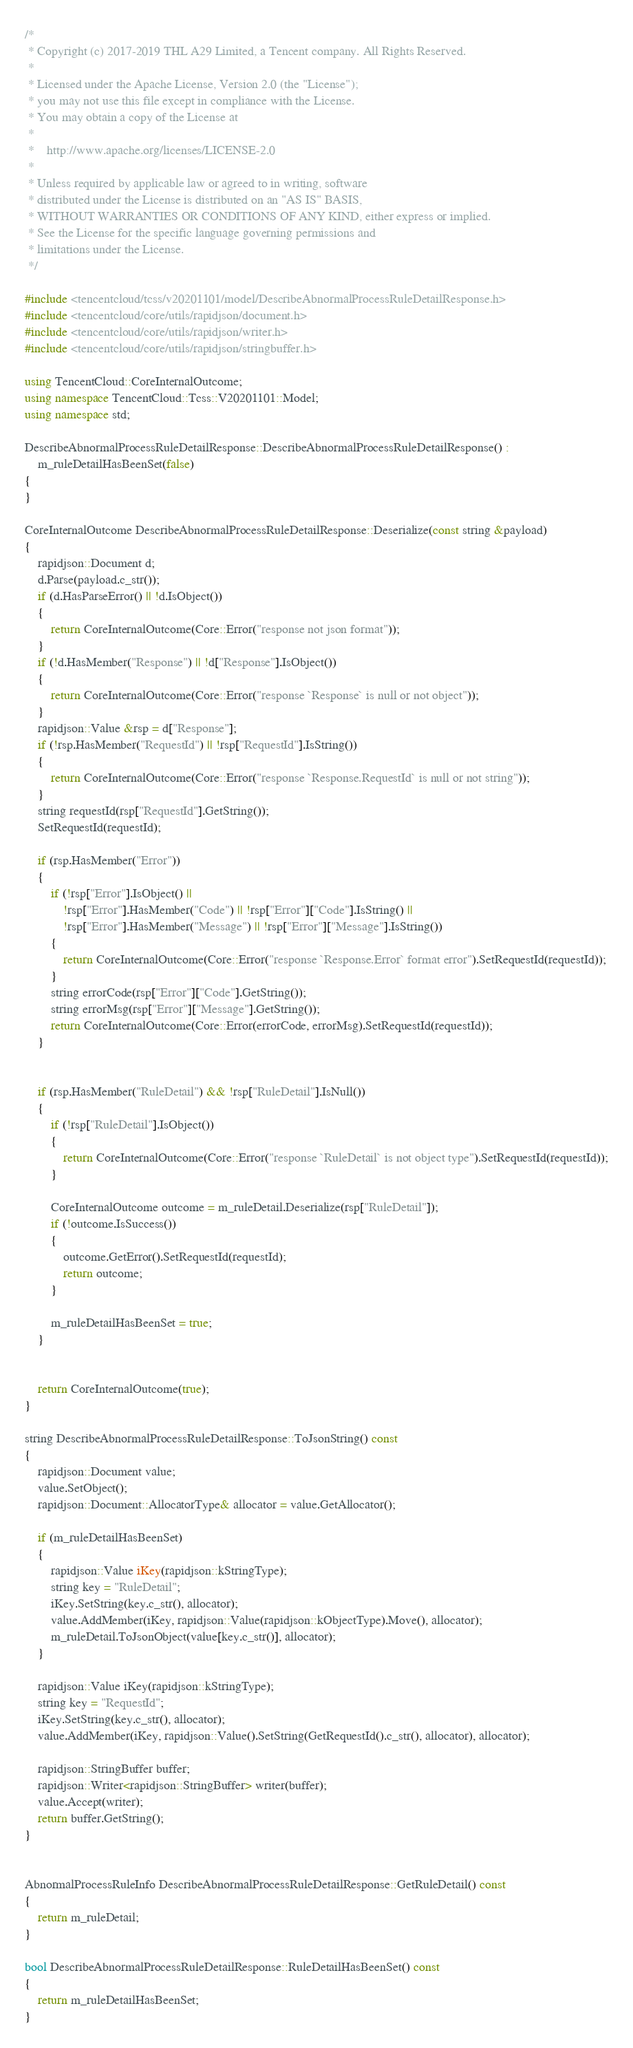Convert code to text. <code><loc_0><loc_0><loc_500><loc_500><_C++_>/*
 * Copyright (c) 2017-2019 THL A29 Limited, a Tencent company. All Rights Reserved.
 *
 * Licensed under the Apache License, Version 2.0 (the "License");
 * you may not use this file except in compliance with the License.
 * You may obtain a copy of the License at
 *
 *    http://www.apache.org/licenses/LICENSE-2.0
 *
 * Unless required by applicable law or agreed to in writing, software
 * distributed under the License is distributed on an "AS IS" BASIS,
 * WITHOUT WARRANTIES OR CONDITIONS OF ANY KIND, either express or implied.
 * See the License for the specific language governing permissions and
 * limitations under the License.
 */

#include <tencentcloud/tcss/v20201101/model/DescribeAbnormalProcessRuleDetailResponse.h>
#include <tencentcloud/core/utils/rapidjson/document.h>
#include <tencentcloud/core/utils/rapidjson/writer.h>
#include <tencentcloud/core/utils/rapidjson/stringbuffer.h>

using TencentCloud::CoreInternalOutcome;
using namespace TencentCloud::Tcss::V20201101::Model;
using namespace std;

DescribeAbnormalProcessRuleDetailResponse::DescribeAbnormalProcessRuleDetailResponse() :
    m_ruleDetailHasBeenSet(false)
{
}

CoreInternalOutcome DescribeAbnormalProcessRuleDetailResponse::Deserialize(const string &payload)
{
    rapidjson::Document d;
    d.Parse(payload.c_str());
    if (d.HasParseError() || !d.IsObject())
    {
        return CoreInternalOutcome(Core::Error("response not json format"));
    }
    if (!d.HasMember("Response") || !d["Response"].IsObject())
    {
        return CoreInternalOutcome(Core::Error("response `Response` is null or not object"));
    }
    rapidjson::Value &rsp = d["Response"];
    if (!rsp.HasMember("RequestId") || !rsp["RequestId"].IsString())
    {
        return CoreInternalOutcome(Core::Error("response `Response.RequestId` is null or not string"));
    }
    string requestId(rsp["RequestId"].GetString());
    SetRequestId(requestId);

    if (rsp.HasMember("Error"))
    {
        if (!rsp["Error"].IsObject() ||
            !rsp["Error"].HasMember("Code") || !rsp["Error"]["Code"].IsString() ||
            !rsp["Error"].HasMember("Message") || !rsp["Error"]["Message"].IsString())
        {
            return CoreInternalOutcome(Core::Error("response `Response.Error` format error").SetRequestId(requestId));
        }
        string errorCode(rsp["Error"]["Code"].GetString());
        string errorMsg(rsp["Error"]["Message"].GetString());
        return CoreInternalOutcome(Core::Error(errorCode, errorMsg).SetRequestId(requestId));
    }


    if (rsp.HasMember("RuleDetail") && !rsp["RuleDetail"].IsNull())
    {
        if (!rsp["RuleDetail"].IsObject())
        {
            return CoreInternalOutcome(Core::Error("response `RuleDetail` is not object type").SetRequestId(requestId));
        }

        CoreInternalOutcome outcome = m_ruleDetail.Deserialize(rsp["RuleDetail"]);
        if (!outcome.IsSuccess())
        {
            outcome.GetError().SetRequestId(requestId);
            return outcome;
        }

        m_ruleDetailHasBeenSet = true;
    }


    return CoreInternalOutcome(true);
}

string DescribeAbnormalProcessRuleDetailResponse::ToJsonString() const
{
    rapidjson::Document value;
    value.SetObject();
    rapidjson::Document::AllocatorType& allocator = value.GetAllocator();

    if (m_ruleDetailHasBeenSet)
    {
        rapidjson::Value iKey(rapidjson::kStringType);
        string key = "RuleDetail";
        iKey.SetString(key.c_str(), allocator);
        value.AddMember(iKey, rapidjson::Value(rapidjson::kObjectType).Move(), allocator);
        m_ruleDetail.ToJsonObject(value[key.c_str()], allocator);
    }

    rapidjson::Value iKey(rapidjson::kStringType);
    string key = "RequestId";
    iKey.SetString(key.c_str(), allocator);
    value.AddMember(iKey, rapidjson::Value().SetString(GetRequestId().c_str(), allocator), allocator);
    
    rapidjson::StringBuffer buffer;
    rapidjson::Writer<rapidjson::StringBuffer> writer(buffer);
    value.Accept(writer);
    return buffer.GetString();
}


AbnormalProcessRuleInfo DescribeAbnormalProcessRuleDetailResponse::GetRuleDetail() const
{
    return m_ruleDetail;
}

bool DescribeAbnormalProcessRuleDetailResponse::RuleDetailHasBeenSet() const
{
    return m_ruleDetailHasBeenSet;
}


</code> 